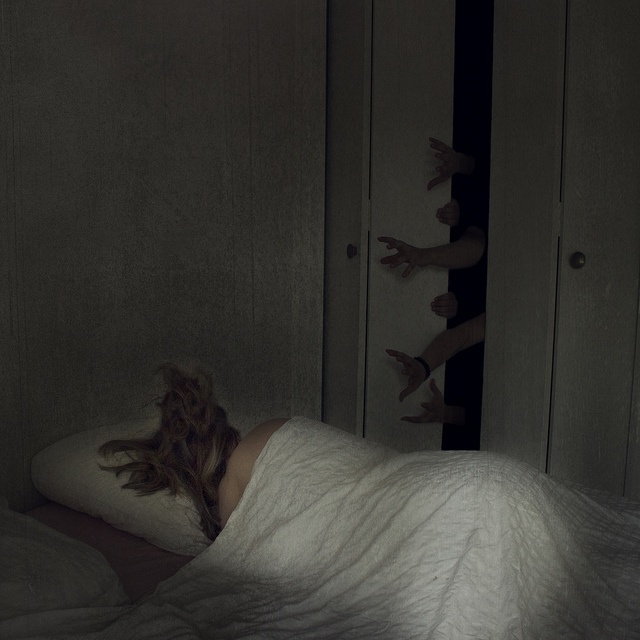Describe the objects in this image and their specific colors. I can see bed in black and gray tones, people in black and gray tones, people in black tones, people in black tones, and people in black tones in this image. 